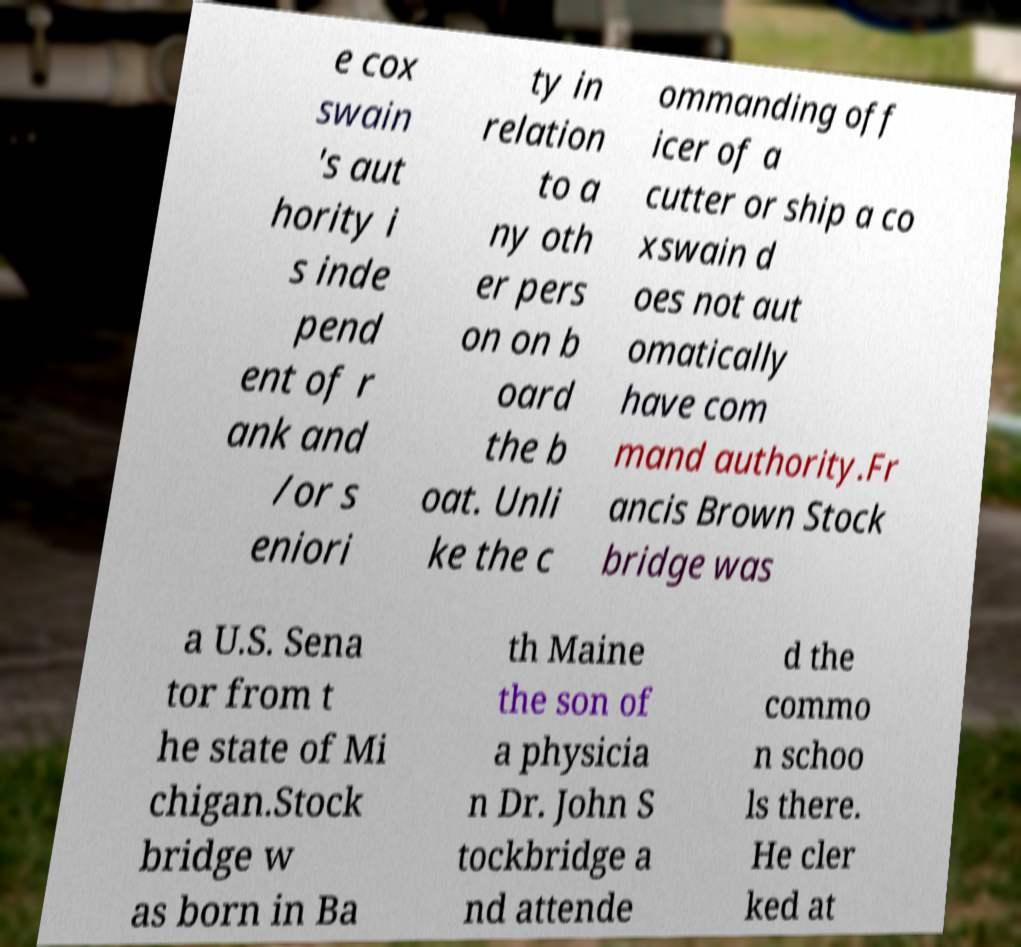For documentation purposes, I need the text within this image transcribed. Could you provide that? e cox swain 's aut hority i s inde pend ent of r ank and /or s eniori ty in relation to a ny oth er pers on on b oard the b oat. Unli ke the c ommanding off icer of a cutter or ship a co xswain d oes not aut omatically have com mand authority.Fr ancis Brown Stock bridge was a U.S. Sena tor from t he state of Mi chigan.Stock bridge w as born in Ba th Maine the son of a physicia n Dr. John S tockbridge a nd attende d the commo n schoo ls there. He cler ked at 